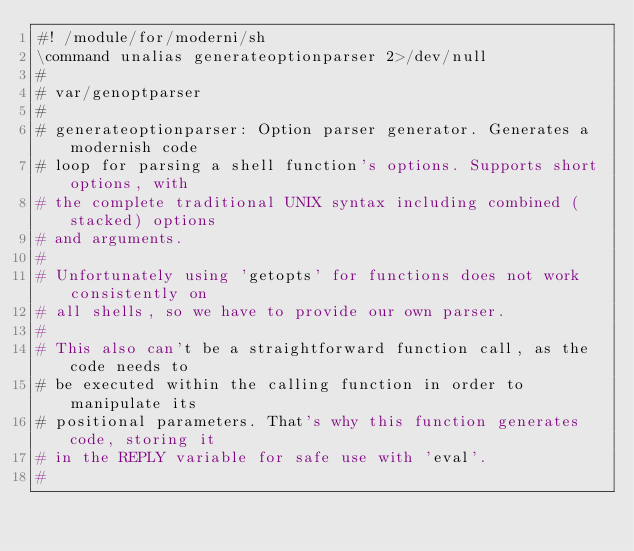Convert code to text. <code><loc_0><loc_0><loc_500><loc_500><_ObjectiveC_>#! /module/for/moderni/sh
\command unalias generateoptionparser 2>/dev/null
#
# var/genoptparser
#
# generateoptionparser: Option parser generator. Generates a modernish code
# loop for parsing a shell function's options. Supports short options, with
# the complete traditional UNIX syntax including combined (stacked) options
# and arguments.
#
# Unfortunately using 'getopts' for functions does not work consistently on
# all shells, so we have to provide our own parser.
#
# This also can't be a straightforward function call, as the code needs to
# be executed within the calling function in order to manipulate its
# positional parameters. That's why this function generates code, storing it
# in the REPLY variable for safe use with 'eval'.
#</code> 